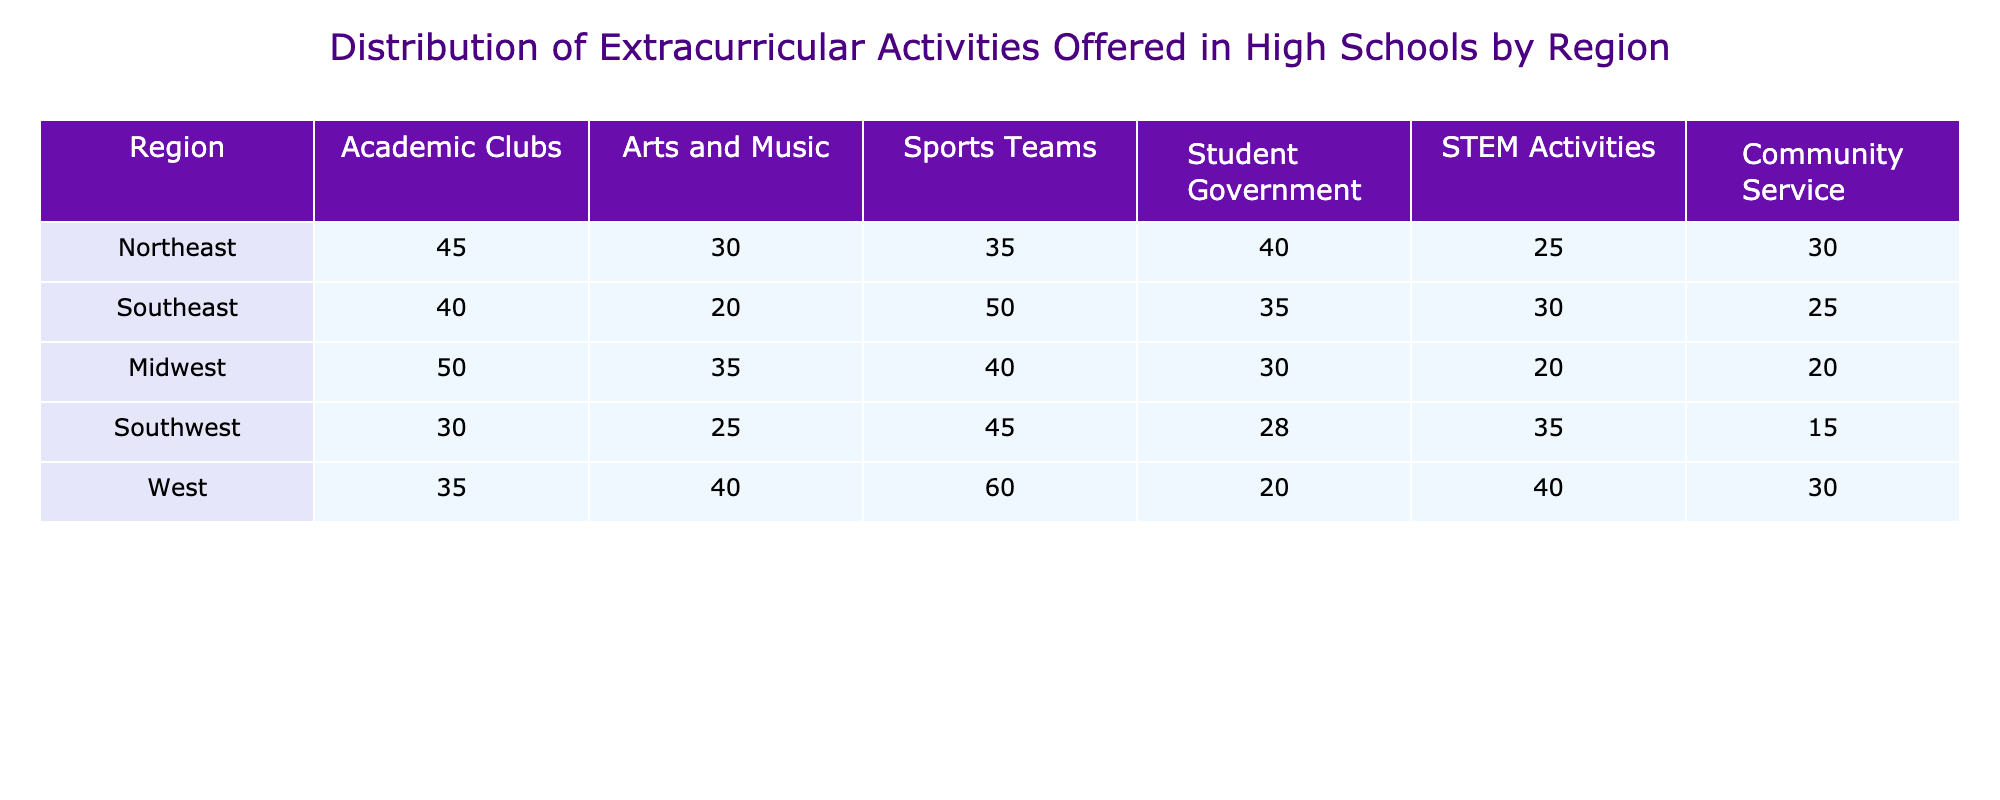What region has the highest number of Sports Teams? Looking at the Sports Teams column, the values for each region are: Northeast (35), Southeast (50), Midwest (40), Southwest (45), and West (60). The highest value is in the West region with 60 Sports Teams.
Answer: West Which region has the least number of Community Service activities? The Community Service column shows the following values: Northeast (30), Southeast (25), Midwest (20), Southwest (15), and West (30). The lowest value is 15, which is in the Southwest region.
Answer: Southwest What is the average number of Academic Clubs across all regions? To find the average number of Academic Clubs, we sum the values: 45 + 40 + 50 + 30 + 35 = 200. There are 5 regions, so the average is 200 / 5 = 40.
Answer: 40 Is it true that the Southwest region offers more Arts and Music activities than the Northeast region? The Northeast region offers 30 Arts and Music activities, while the Southwest region offers 25. Since 25 is less than 30, the statement is false.
Answer: No What is the total number of STEM Activities across all regions? The STEM Activities values are: Northeast (25), Southeast (30), Midwest (20), Southwest (35), and West (40). Summing these gives 25 + 30 + 20 + 35 + 40 = 150, thus the total is 150.
Answer: 150 Which region has the highest number of Student Government activities and how does it compare with the lowest? The values for Student Government activities are: Northeast (40), Southeast (35), Midwest (30), Southwest (28), and West (20). The highest is in the Northeast with 40, and the lowest is in the West with 20. The difference is 40 - 20 = 20.
Answer: 20 How many more Sports Teams does the Southeast offer compared to the Northeast? The Southeast region has 50 Sports Teams, and the Northeast has 35. Subtracting these gives 50 - 35 = 15, meaning the Southeast has 15 more Sports Teams than the Northeast.
Answer: 15 What is the total count of Arts and Music activities in the Midwest and Southwest combined? For the Midwest, there are 35 Arts and Music activities, and for the Southwest, there are 25. Adding these amounts together gives 35 + 25 = 60.
Answer: 60 Is the number of Sports Teams in the West more than that in the Southeast? The West has 60 Sports Teams, whereas the Southeast has 50. Since 60 is greater than 50, the statement is true.
Answer: Yes 